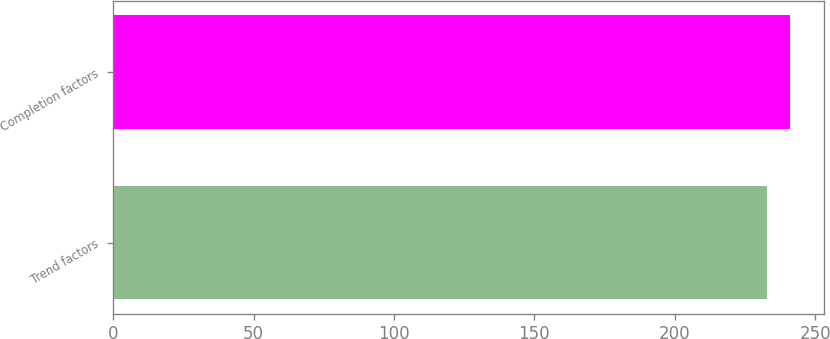Convert chart to OTSL. <chart><loc_0><loc_0><loc_500><loc_500><bar_chart><fcel>Trend factors<fcel>Completion factors<nl><fcel>233<fcel>241<nl></chart> 